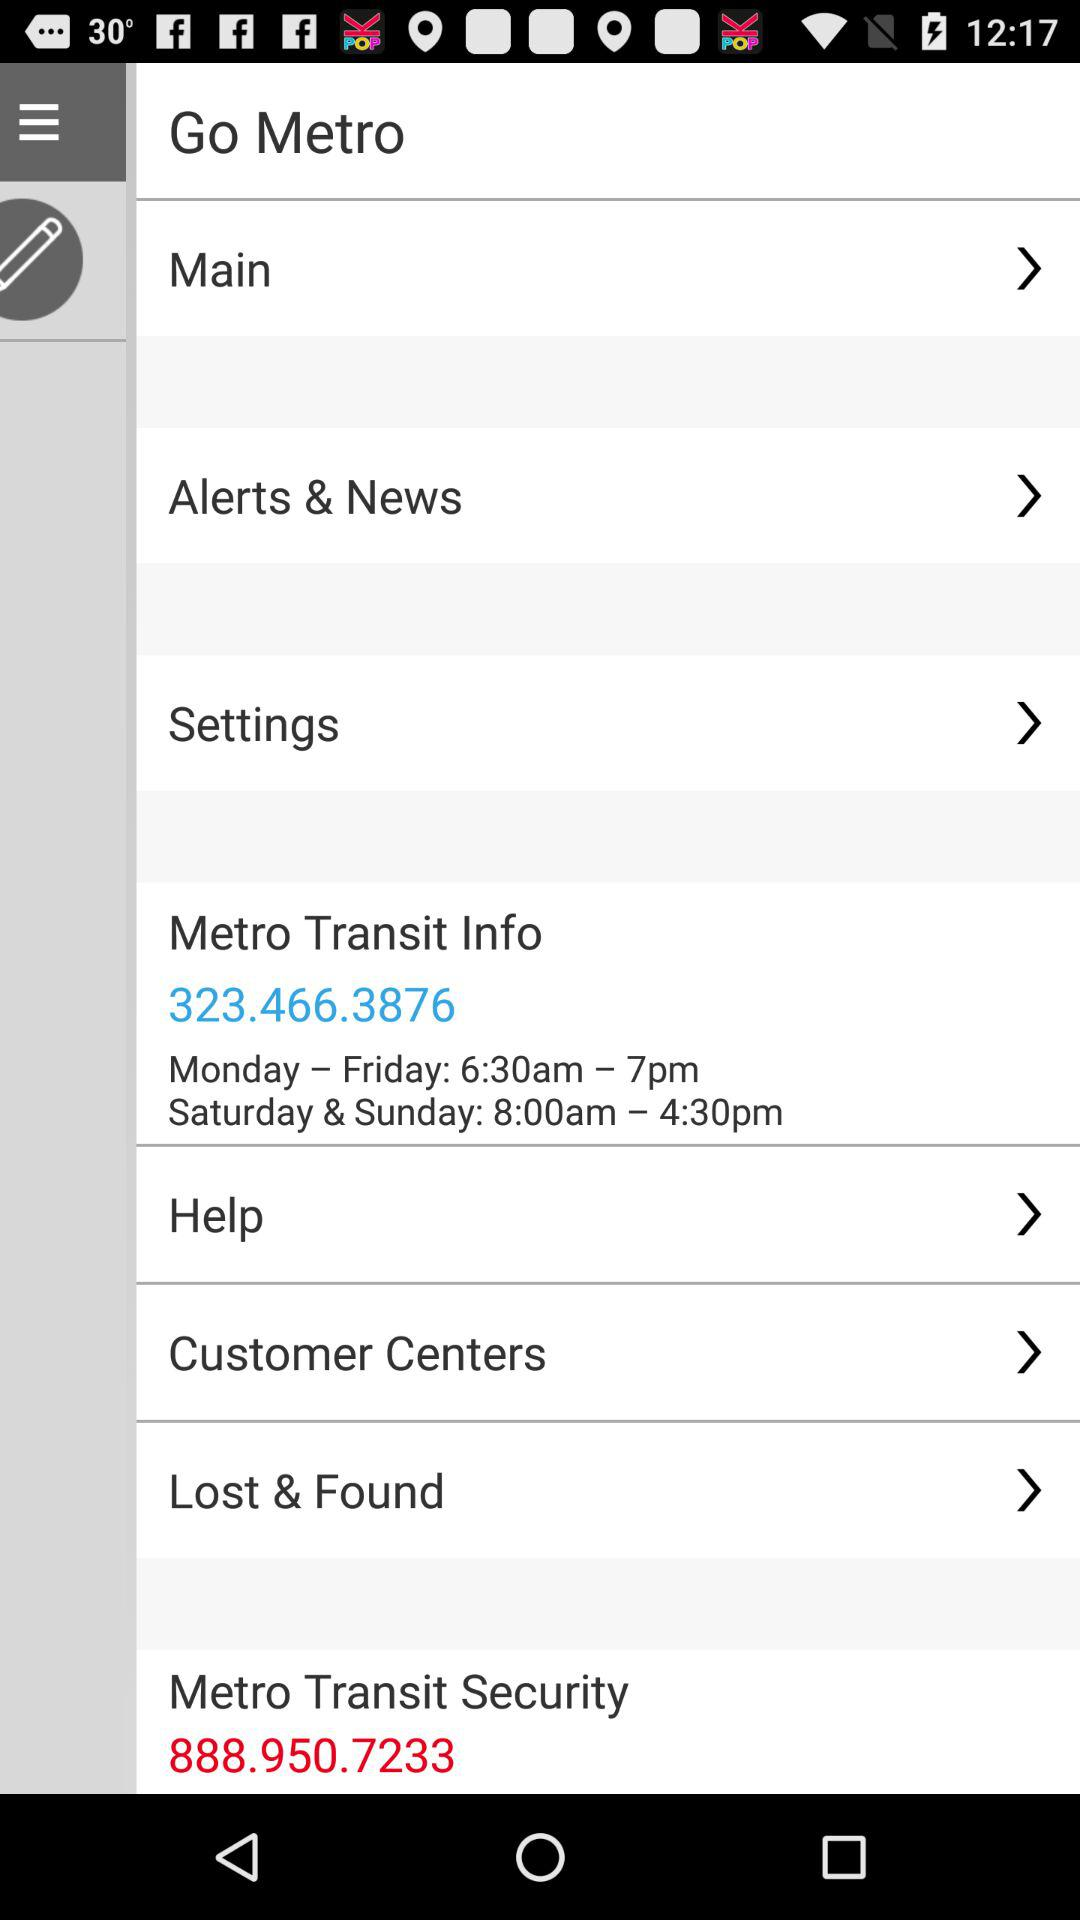What is the information timing? The information timing is 6:30 am to 7 pm from Monday to Friday and 8:00 am to 4:30 pm on Saturday and Sunday. 